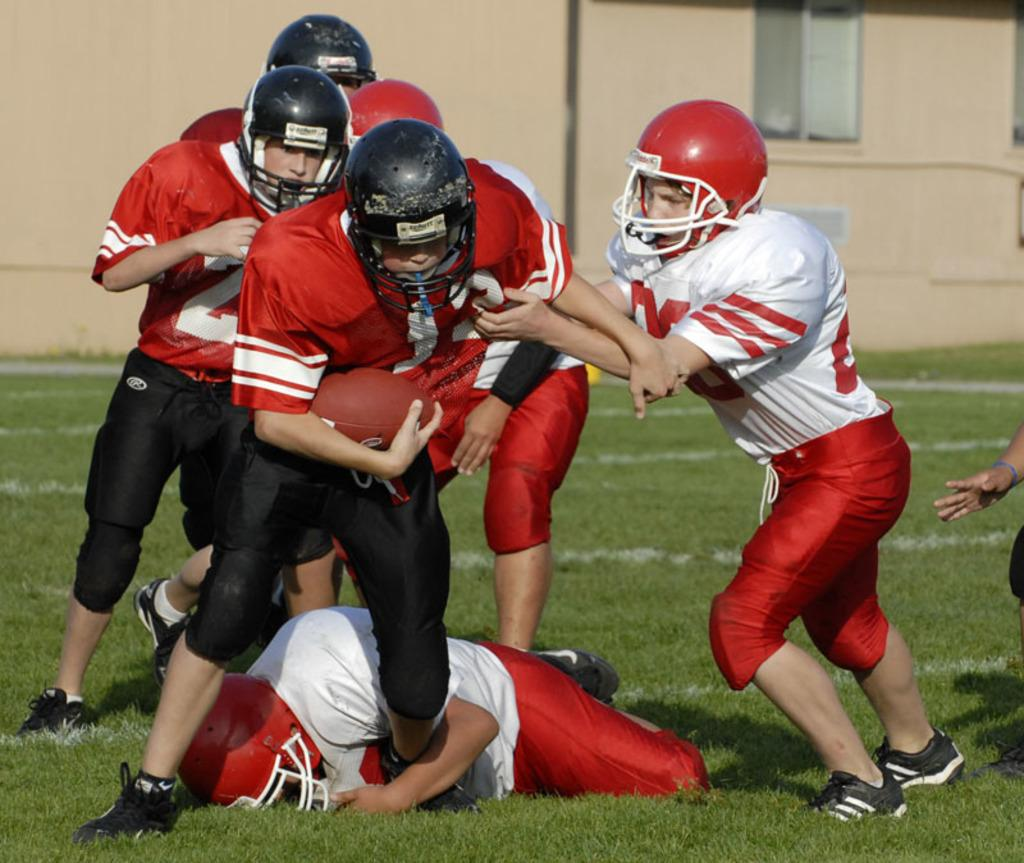What are the persons in the image doing? The persons in the image are playing in the ground. Where are the persons located in the image? The persons are in the center of the image. What can be seen in the background of the image? There is a building in the background of the image. What type of furniture can be seen in the image? There is no furniture present in the image. What color is the frame of the image? The color of the frame is not visible in the image, as we are looking at the image itself and not its frame. 